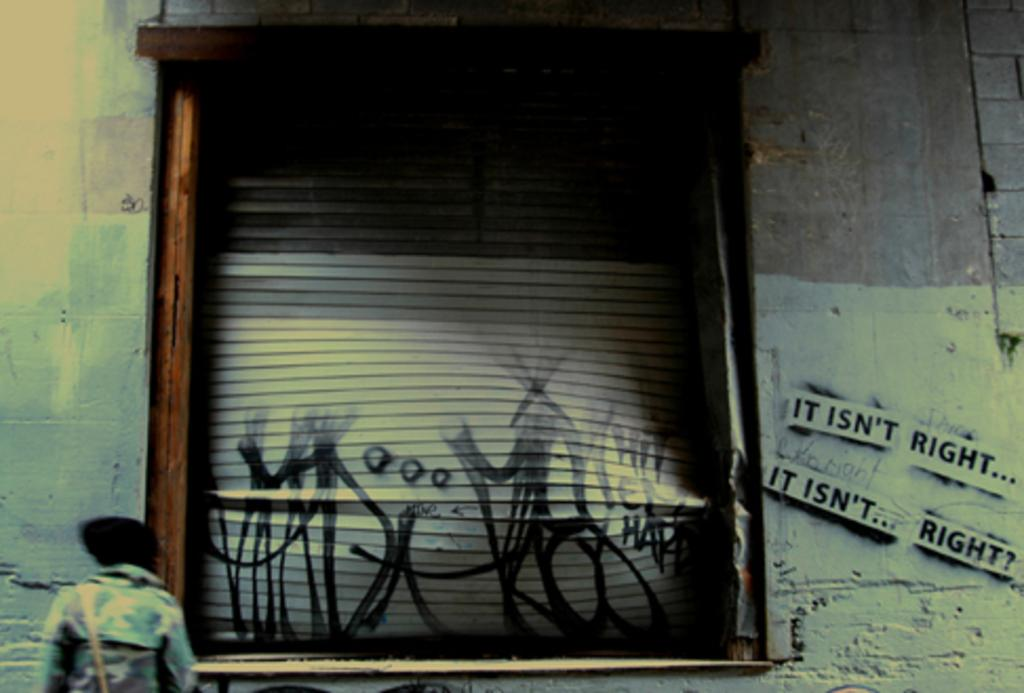What is the man doing in the image? The man is standing in front of the wall. What can be seen on the wall in the image? There is a window in the middle of the wall, and the phrase "it isn't right it, it isn't right" is written on the wall. What type of toothpaste is being used to write on the wall in the image? There is no toothpaste present in the image; the phrase is written on the wall using some other substance or method. 